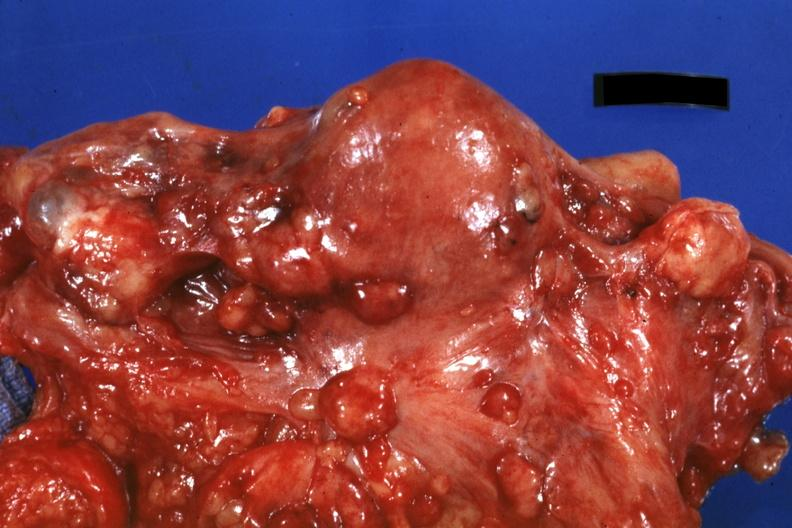what is present?
Answer the question using a single word or phrase. Abdomen 